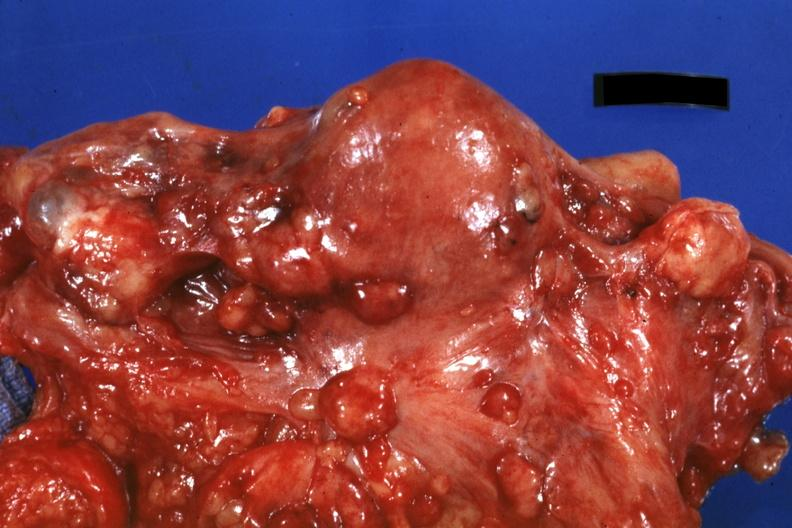what is present?
Answer the question using a single word or phrase. Abdomen 